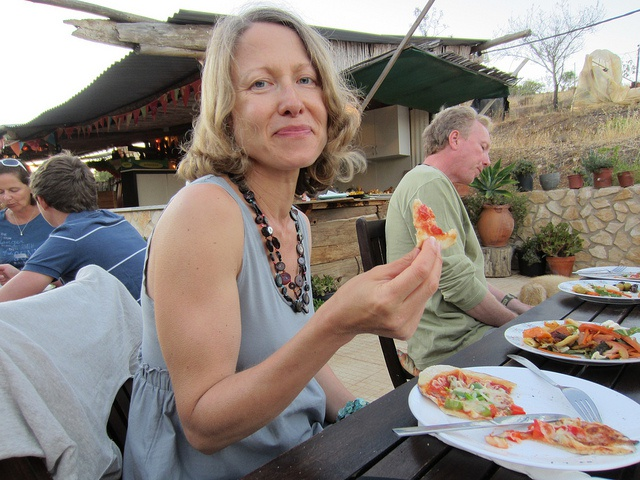Describe the objects in this image and their specific colors. I can see people in white, gray, tan, and darkgray tones, dining table in white, lightgray, gray, black, and darkgray tones, chair in white, darkgray, black, and lightblue tones, people in white, darkgray, and gray tones, and people in white, gray, blue, and black tones in this image. 